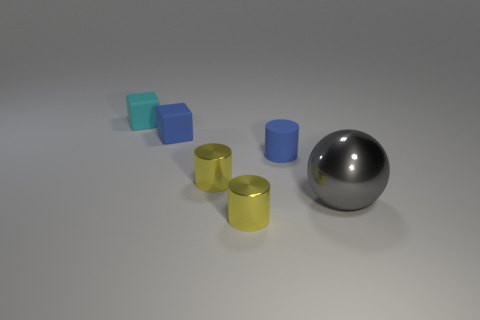Is there anything else that is the same color as the sphere?
Ensure brevity in your answer.  No. There is a thing behind the block in front of the cyan block; what size is it?
Your response must be concise. Small. What is the color of the small rubber object that is behind the tiny rubber cylinder and in front of the small cyan thing?
Your response must be concise. Blue. How many other objects are the same size as the blue cylinder?
Offer a very short reply. 4. Is the size of the shiny ball the same as the blue matte object that is in front of the blue matte cube?
Provide a short and direct response. No. There is a cube that is the same size as the cyan rubber object; what is its color?
Offer a very short reply. Blue. What size is the gray sphere?
Offer a very short reply. Large. Does the cylinder in front of the large gray metallic thing have the same material as the big thing?
Your response must be concise. Yes. Does the cyan object have the same shape as the gray object?
Offer a terse response. No. What is the shape of the big gray metal object in front of the yellow thing behind the yellow metallic cylinder in front of the big shiny thing?
Provide a short and direct response. Sphere. 